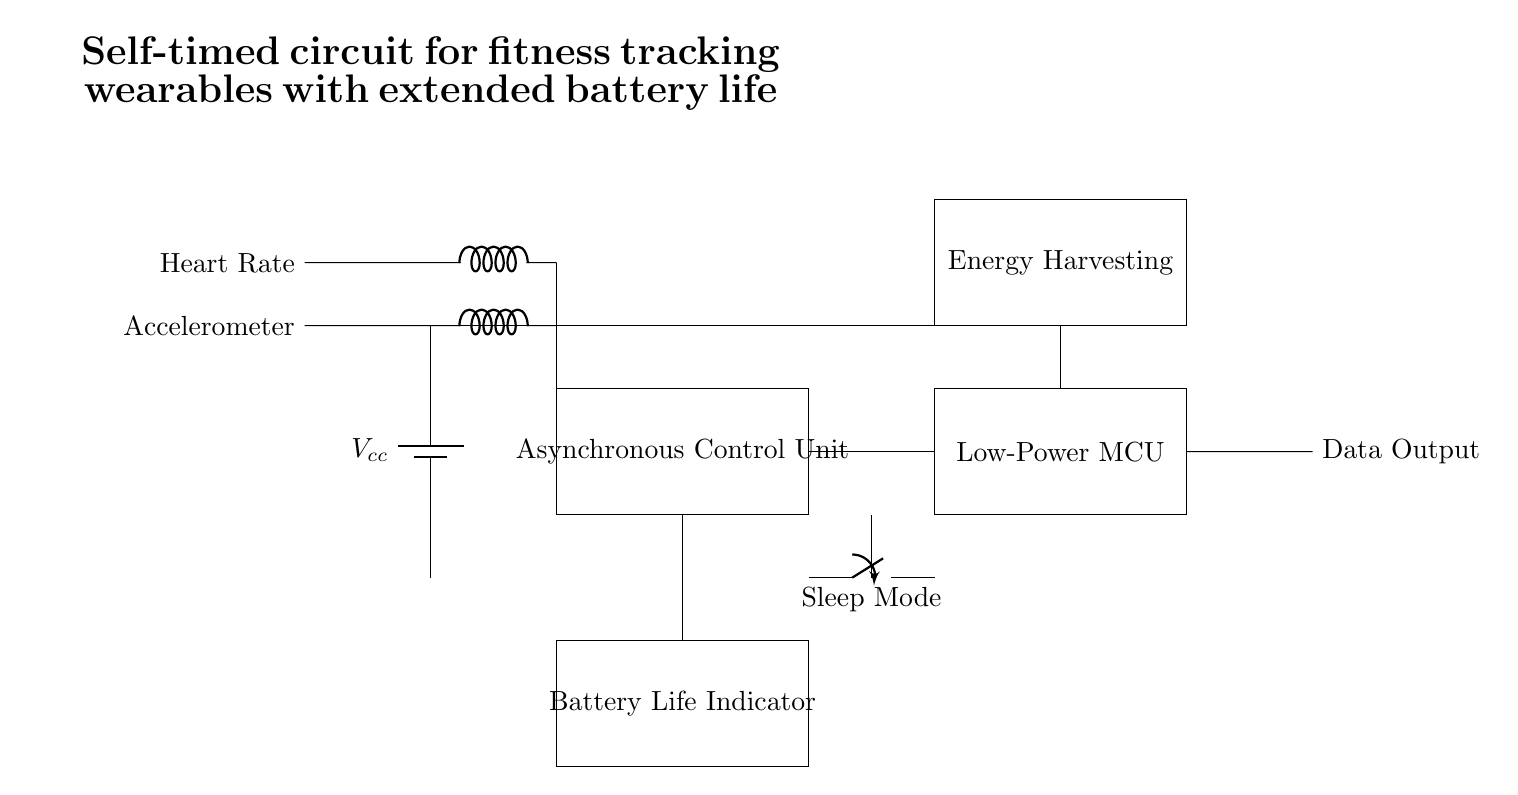What component is responsible for controlling the circuit? The component responsible for controlling the circuit is the Asynchronous Control Unit, which is represented by a rectangle labeled with its function.
Answer: Asynchronous Control Unit What type of power supply is used in the circuit? The circuit uses a battery for power supply, shown at the left with a label indicating its function as Vcc.
Answer: Battery What is the purpose of the energy harvesting unit? The energy harvesting unit is designed to collect energy from the environment, which can extend battery life and provide additional power for the circuit.
Answer: Energy harvesting How many sensor inputs are present in the circuit? There are two sensor inputs shown in the circuit, one for heart rate and another for the accelerometer, with each labeled accordingly.
Answer: Two What does the sleep mode switch do? The sleep mode switch is used to put the system into a low-power state when not in use, conserving battery life by reducing current draw.
Answer: Conserves battery Why is a low-power microcontroller used? A low-power microcontroller is used in this circuit to minimize energy consumption, making the wearable device more efficient and prolonging battery life during operation.
Answer: To minimize energy consumption Which component provides information about battery status? The Battery Life Indicator component is responsible for displaying the status of the battery, helping users to monitor energy levels.
Answer: Battery Life Indicator 